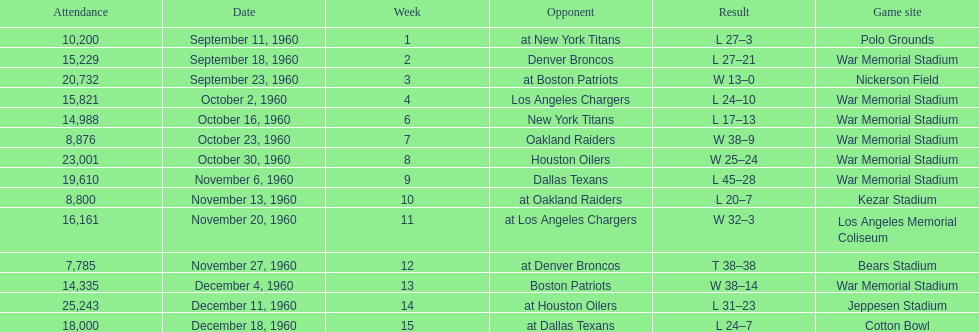How many games had at least 10,000 people in attendance? 11. 